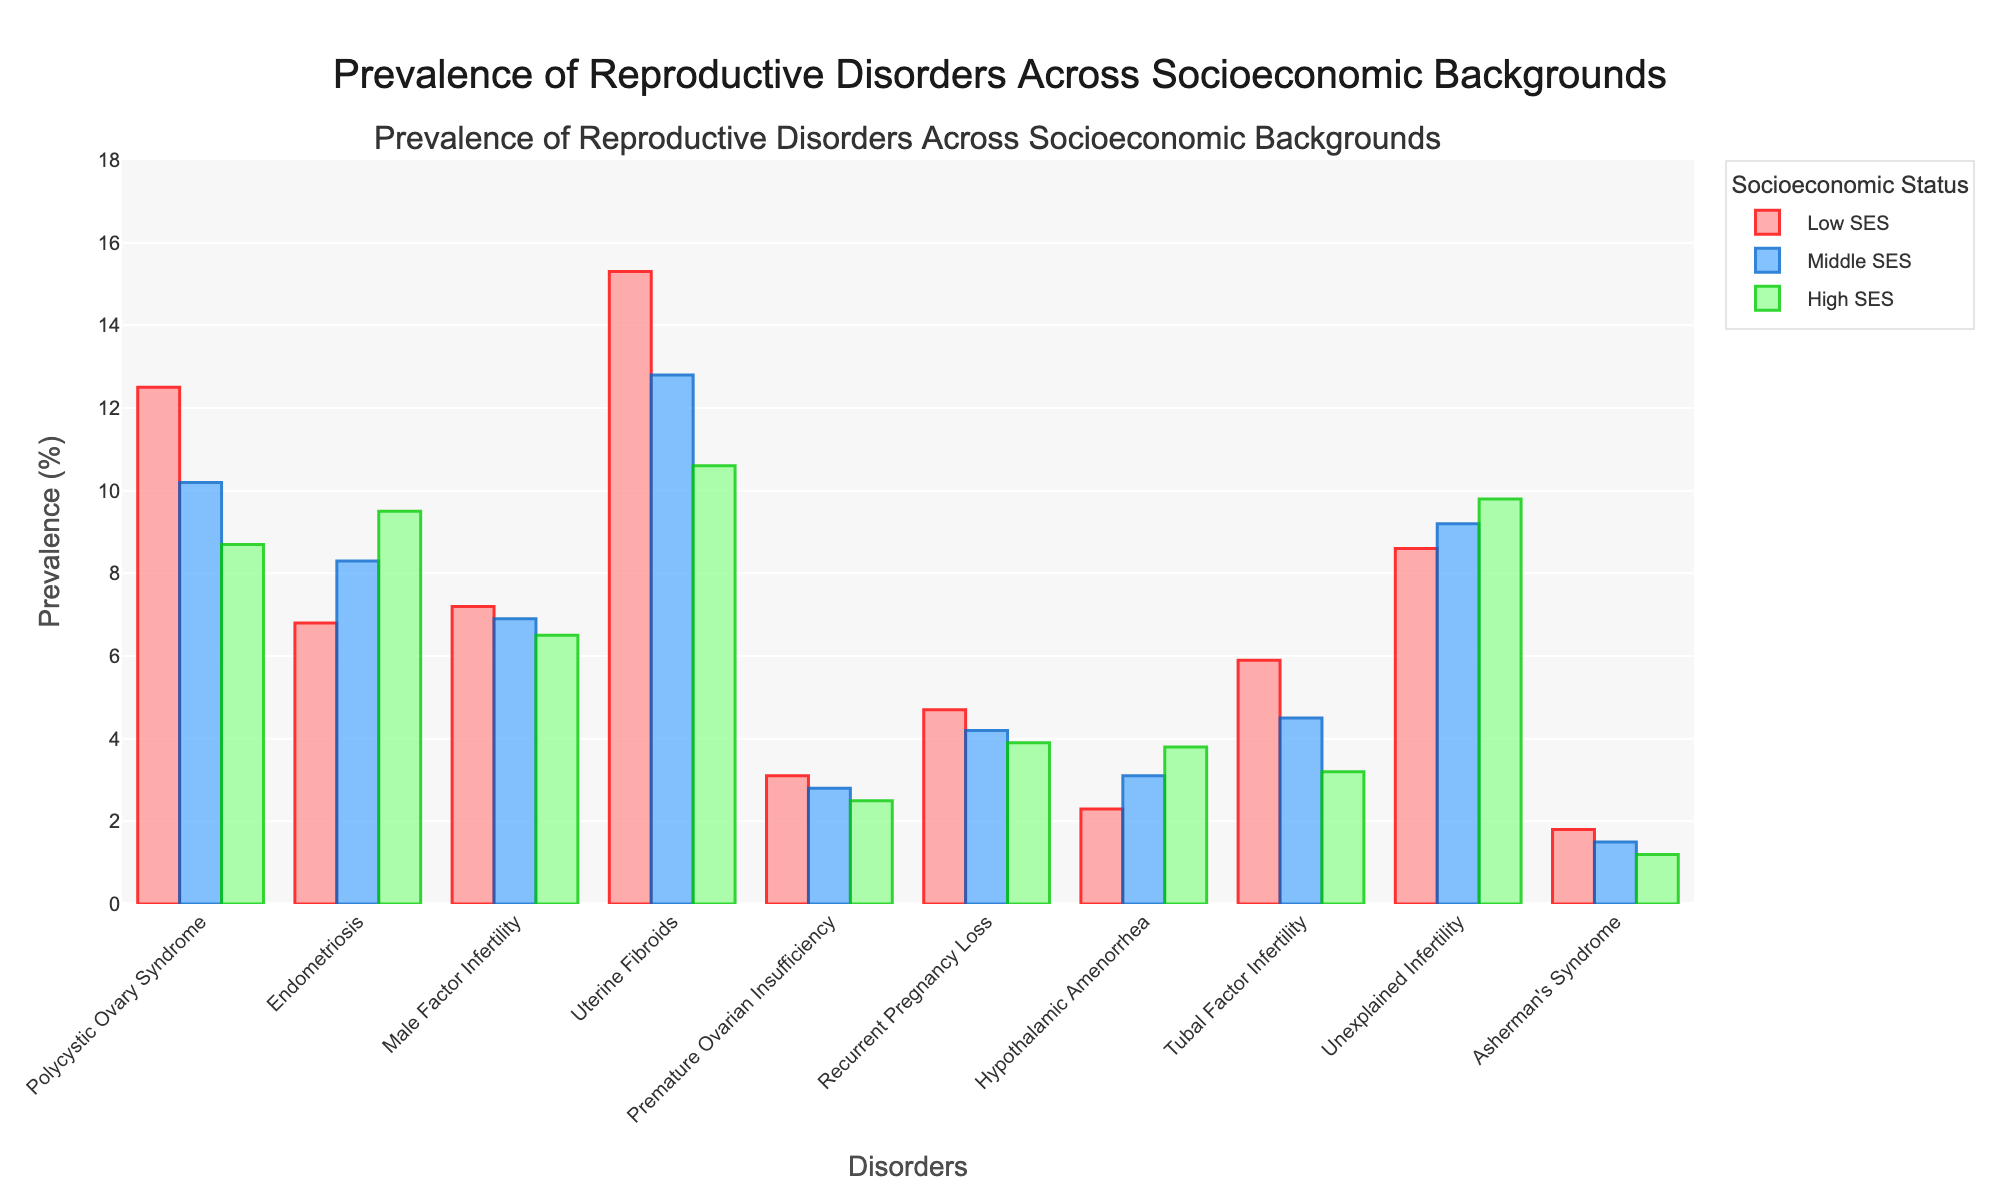What is the difference in prevalence of Uterine Fibroids between Low SES and High SES groups? Uterine Fibroids prevalence in Low SES is 15.3%, and in High SES is 10.6%. The difference is calculated as 15.3% - 10.6% = 4.7%.
Answer: 4.7% Which socioeconomic group has the highest prevalence of Polycystic Ovary Syndrome? The bars representing Polycystic Ovary Syndrome are visually compared. The Low SES group's bar is the tallest at 12.5%.
Answer: Low SES Among Hypothalamic Amenorrhea, which SES group has the lowest prevalence? By comparing the bar heights for Hypothalamic Amenorrhea, the Low SES group's bar is the shortest at 2.3%.
Answer: Low SES What is the total prevalence of Male Factor Infertility across all SES groups? Adding the values for Male Factor Infertility: 7.2% (Low SES) + 6.9% (Middle SES) + 6.5% (High SES) = 20.6%.
Answer: 20.6% Which disorder shows a reverse trend, increasing in prevalence from Low SES to High SES? By examining the trends, Endometriosis shows an increase: 6.8% (Low SES), 8.3% (Middle SES), 9.5% (High SES).
Answer: Endometriosis What is the average prevalence of Tubal Factor Infertility across the Middle and High SES groups? Adding the prevalence values for Tubal Factor Infertility in Middle and High SES groups: 4.5% + 3.2% = 7.7%. Then, divide by 2 to find the average: 7.7% / 2 = 3.85%.
Answer: 3.85% Compare the prevalence of Unexplained Infertility in Low SES to Endometriosis in Low SES. Which is higher? Unexplained Infertility in Low SES is 8.6%, while Endometriosis in Low SES is 6.8%. Thus, Unexplained Infertility is higher in Low SES.
Answer: Unexplained Infertility Which disorders have a higher prevalence in High SES than Middle SES? By comparing the bars for High SES and Middle SES, both Endometriosis (9.5% > 8.3%) and Unexplained Infertility (9.8% > 9.2%) are higher in High SES than Middle SES.
Answer: Endometriosis, Unexplained Infertility What is the combined prevalence of Asherman's Syndrome in all SES groups? Adding the prevalence values for Asherman's Syndrome: 1.8% (Low SES) + 1.5% (Middle SES) + 1.2% (High SES) = 4.5%.
Answer: 4.5% Which disorder shows a decreasing trend from Low SES to High SES? By observing the trends, Polycystic Ovary Syndrome decreases from 12.5% (Low SES) to 10.2% (Middle SES) to 8.7% (High SES).
Answer: Polycystic Ovary Syndrome 